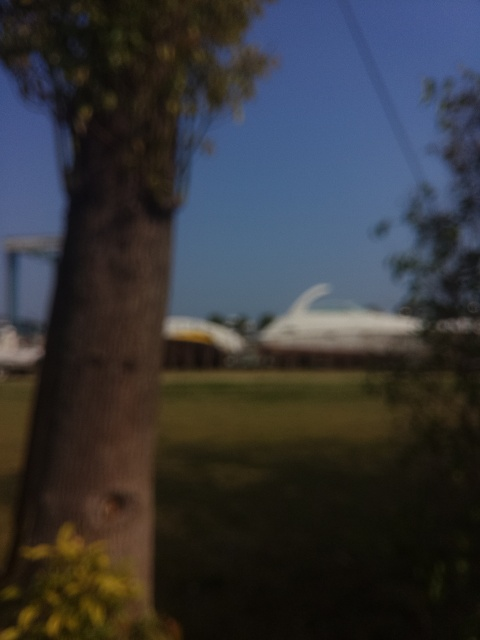What might be the reason for taking a photo with such a blur? Is it a stylistic choice or an error? The blur could be the result of several factors; it might be an intentional artistic choice to convey a mood or theme, or it could simply be an accidental result of camera movement, incorrect focus, or settings not suited for the lighting conditions. The context in which the photo was taken would provide more insight into whether it was deliberate or not. 